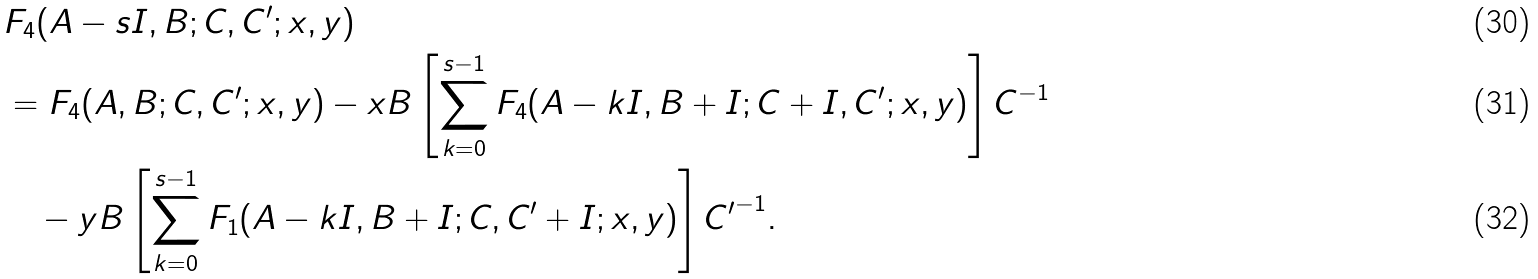Convert formula to latex. <formula><loc_0><loc_0><loc_500><loc_500>& F _ { 4 } ( A - s I , B ; C , C ^ { \prime } ; x , y ) \\ & = F _ { 4 } ( A , B ; C , C ^ { \prime } ; x , y ) - x { B } \left [ \sum _ { k = 0 } ^ { s - 1 } F _ { 4 } ( A - k I , B + I ; C + I , C ^ { \prime } ; x , y ) \right ] { C } ^ { - 1 } \\ & \quad - y { B } \left [ \sum _ { k = 0 } ^ { s - 1 } F _ { 1 } ( A - k I , B + I ; C , C ^ { \prime } + I ; x , y ) \right ] { C ^ { \prime } } ^ { - 1 } .</formula> 